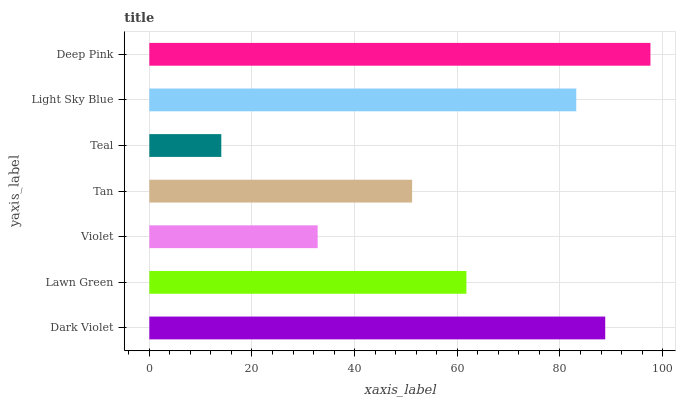Is Teal the minimum?
Answer yes or no. Yes. Is Deep Pink the maximum?
Answer yes or no. Yes. Is Lawn Green the minimum?
Answer yes or no. No. Is Lawn Green the maximum?
Answer yes or no. No. Is Dark Violet greater than Lawn Green?
Answer yes or no. Yes. Is Lawn Green less than Dark Violet?
Answer yes or no. Yes. Is Lawn Green greater than Dark Violet?
Answer yes or no. No. Is Dark Violet less than Lawn Green?
Answer yes or no. No. Is Lawn Green the high median?
Answer yes or no. Yes. Is Lawn Green the low median?
Answer yes or no. Yes. Is Violet the high median?
Answer yes or no. No. Is Tan the low median?
Answer yes or no. No. 